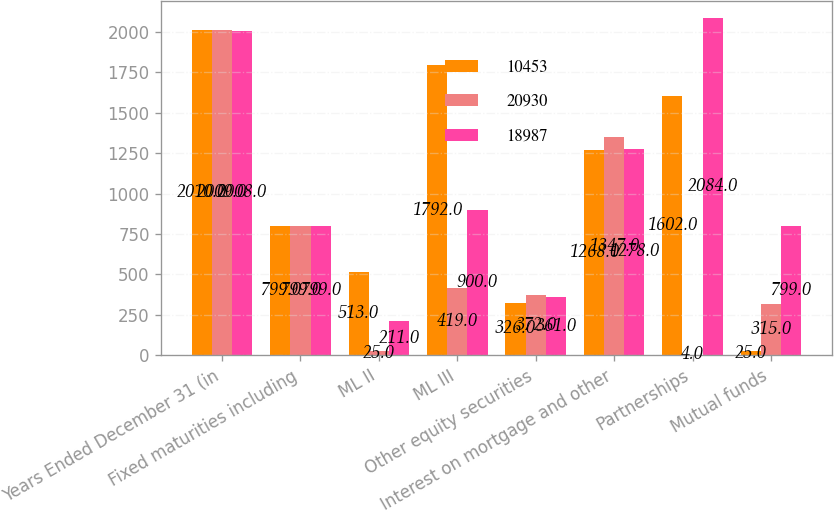Convert chart to OTSL. <chart><loc_0><loc_0><loc_500><loc_500><stacked_bar_chart><ecel><fcel>Years Ended December 31 (in<fcel>Fixed maturities including<fcel>ML II<fcel>ML III<fcel>Other equity securities<fcel>Interest on mortgage and other<fcel>Partnerships<fcel>Mutual funds<nl><fcel>10453<fcel>2010<fcel>799<fcel>513<fcel>1792<fcel>326<fcel>1268<fcel>1602<fcel>25<nl><fcel>20930<fcel>2009<fcel>799<fcel>25<fcel>419<fcel>372<fcel>1347<fcel>4<fcel>315<nl><fcel>18987<fcel>2008<fcel>799<fcel>211<fcel>900<fcel>361<fcel>1278<fcel>2084<fcel>799<nl></chart> 